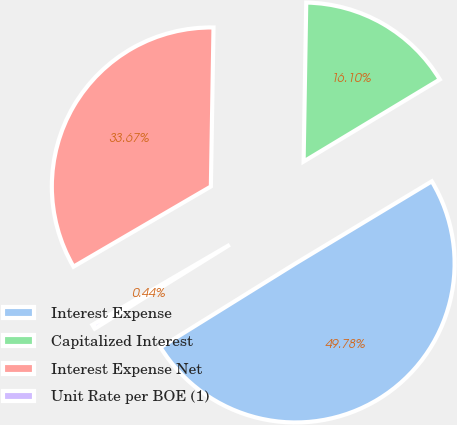<chart> <loc_0><loc_0><loc_500><loc_500><pie_chart><fcel>Interest Expense<fcel>Capitalized Interest<fcel>Interest Expense Net<fcel>Unit Rate per BOE (1)<nl><fcel>49.78%<fcel>16.1%<fcel>33.67%<fcel>0.44%<nl></chart> 